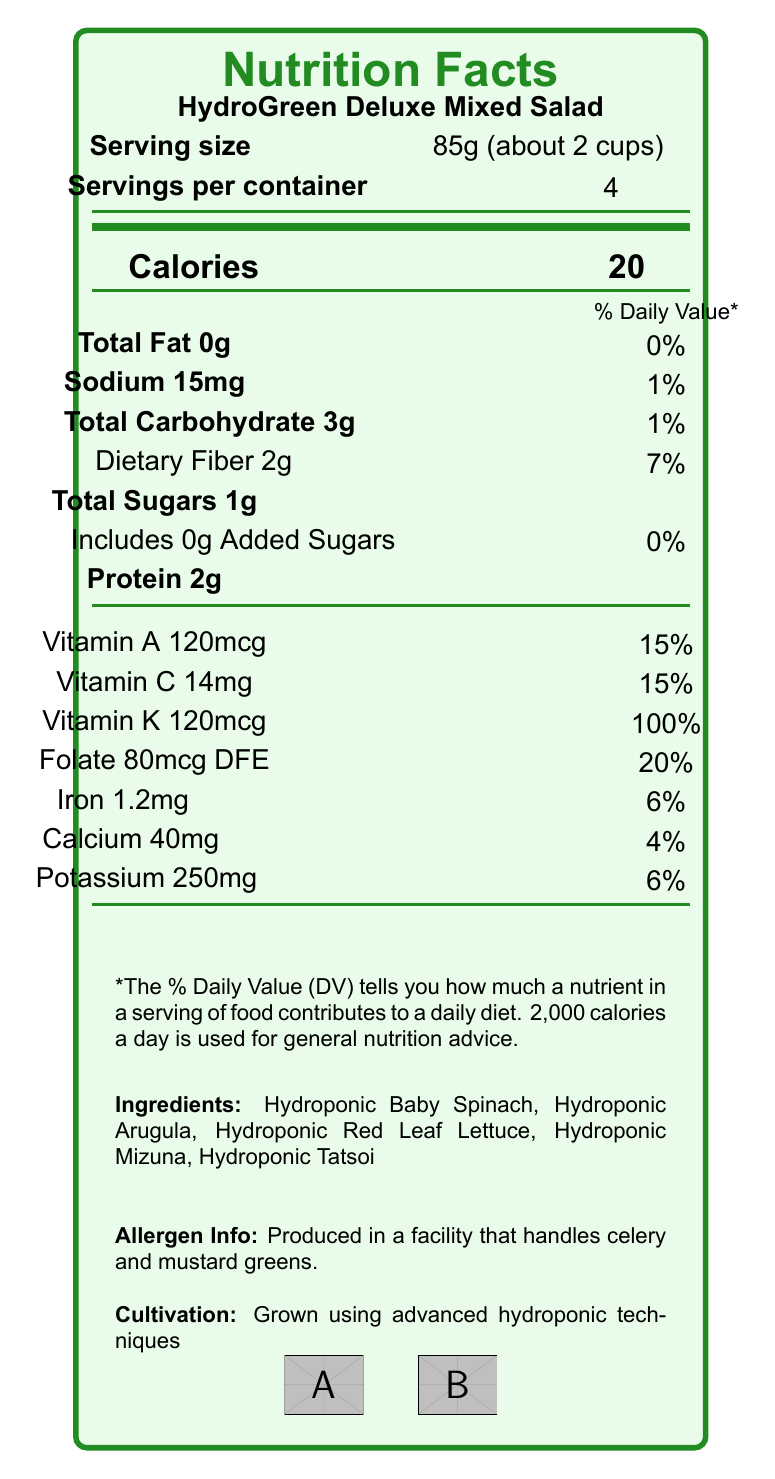What is the serving size of HydroGreen Deluxe Mixed Salad? The document specifies the serving size as 85g, which is approximately 2 cups.
Answer: 85g (about 2 cups) How many calories are in one serving of HydroGreen Deluxe Mixed Salad? The document states that there are 20 calories per serving.
Answer: 20 Which vitamins account for 15% of the Daily Value in this salad? The document lists Vitamin A and Vitamin C both at 15% of the Daily Value per serving.
Answer: Vitamin A and Vitamin C What percentage of the Daily Value for Vitamin K does one serving provide? The document indicates that one serving provides 100% of the Daily Value for Vitamin K.
Answer: 100% How much dietary fiber is in one serving? The document states that there are 2 grams of dietary fiber per serving.
Answer: 2g Which of the following is NOT listed as an ingredient in HydroGreen Deluxe Mixed Salad? A. Hydroponic Baby Spinach B. Hydroponic Arugula C. Hydroponic Kale D. Hydroponic Tatsoi The ingredients listed are Hydroponic Baby Spinach, Hydroponic Arugula, Hydroponic Red Leaf Lettuce, Hydroponic Mizuna, and Hydroponic Tatsoi. Kale is not mentioned.
Answer: C How should you store HydroGreen Deluxe Mixed Salad to maintain its freshness? The document provides the storage instructions: keep refrigerated at 34-38°F (1-3°C) and wash before use.
Answer: Keep refrigerated at 34-38°F (1-3°C). Wash before use. What is the shelf life of HydroGreen Deluxe Mixed Salad? The document states that the shelf life is 7 days from the harvest date when properly stored.
Answer: 7 days from harvest date when properly stored Is the HydroGreen Deluxe Mixed Salad labeled as USDA Organic? The document mentions that the product has USDA Organic certification.
Answer: Yes Does the HydroGreen Deluxe Mixed Salad contain any added sugars? According to the document, the salad contains 1g of total sugars and 0g of added sugars.
Answer: No Which statement is true about the protein content in each serving? A. It contains 0g of protein B. It contains more protein than total carbohydrates C. It contains 2g of protein D. It contains the most iron per serving The document states that each serving contains 2g of protein.
Answer: C What is the total amount of sodium in one container of HydroGreen Deluxe Mixed Salad? Given that there are 15mg of sodium per serving and 4 servings per container, the total sodium is 15mg * 4 = 60mg.
Answer: 60mg Is the packaging of HydroGreen Deluxe Mixed Salad recyclable? The document notes that the packaging is a 100% recyclable clamshell container.
Answer: Yes Summarize the details provided in the nutrition facts label for HydroGreen Deluxe Mixed Salad. The provided information encompasses serving size, calories, fats, sodium, carbohydrates, dietary fiber, sugars, protein, vitamins, and minerals content, as well as storage instructions, shelf life, certifications, and type of packaging.
Answer: HydroGreen Deluxe Mixed Salad is a hydroponically grown product containing a mix of baby spinach, arugula, red leaf lettuce, mizuna, and tatsoi. Each 85g serving (around 2 cups) has 20 calories, 0g fat, 15mg sodium, 3g carbohydrates, 2g dietary fiber, 1g total sugars with 0g added sugars, 2g protein, and provides various vitamins and minerals including 100% DV of Vitamin K, 15% DV of Vitamin A and C, and significant amounts of folate, iron, calcium, and potassium. It should be kept refrigerated and has a shelf life of 7 days. The product is USDA Organic and Non-GMO Project Verified, with its packaging being 100% recyclable. What is the source of potassium in this product? The document lists the total amount of potassium (250mg) per serving but does not specify the specific source ingredients for potassium.
Answer: Not enough information 